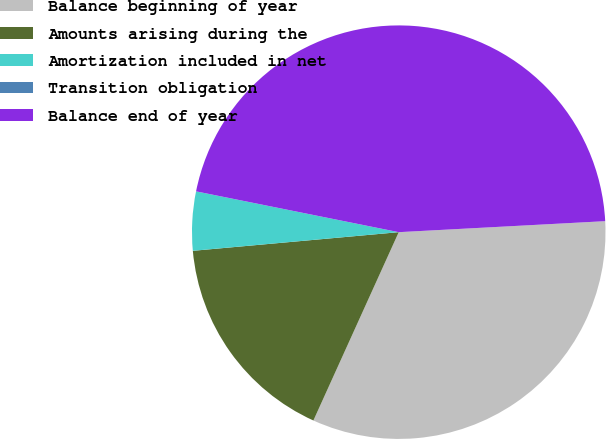<chart> <loc_0><loc_0><loc_500><loc_500><pie_chart><fcel>Balance beginning of year<fcel>Amounts arising during the<fcel>Amortization included in net<fcel>Transition obligation<fcel>Balance end of year<nl><fcel>32.62%<fcel>16.79%<fcel>4.6%<fcel>0.0%<fcel>45.99%<nl></chart> 